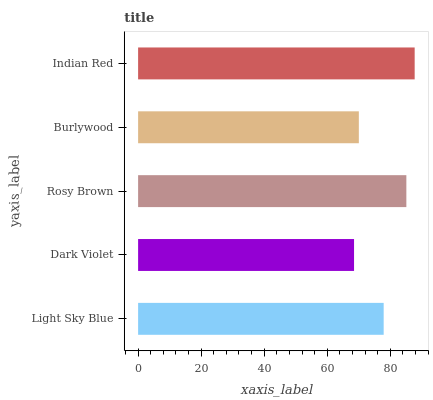Is Dark Violet the minimum?
Answer yes or no. Yes. Is Indian Red the maximum?
Answer yes or no. Yes. Is Rosy Brown the minimum?
Answer yes or no. No. Is Rosy Brown the maximum?
Answer yes or no. No. Is Rosy Brown greater than Dark Violet?
Answer yes or no. Yes. Is Dark Violet less than Rosy Brown?
Answer yes or no. Yes. Is Dark Violet greater than Rosy Brown?
Answer yes or no. No. Is Rosy Brown less than Dark Violet?
Answer yes or no. No. Is Light Sky Blue the high median?
Answer yes or no. Yes. Is Light Sky Blue the low median?
Answer yes or no. Yes. Is Indian Red the high median?
Answer yes or no. No. Is Indian Red the low median?
Answer yes or no. No. 